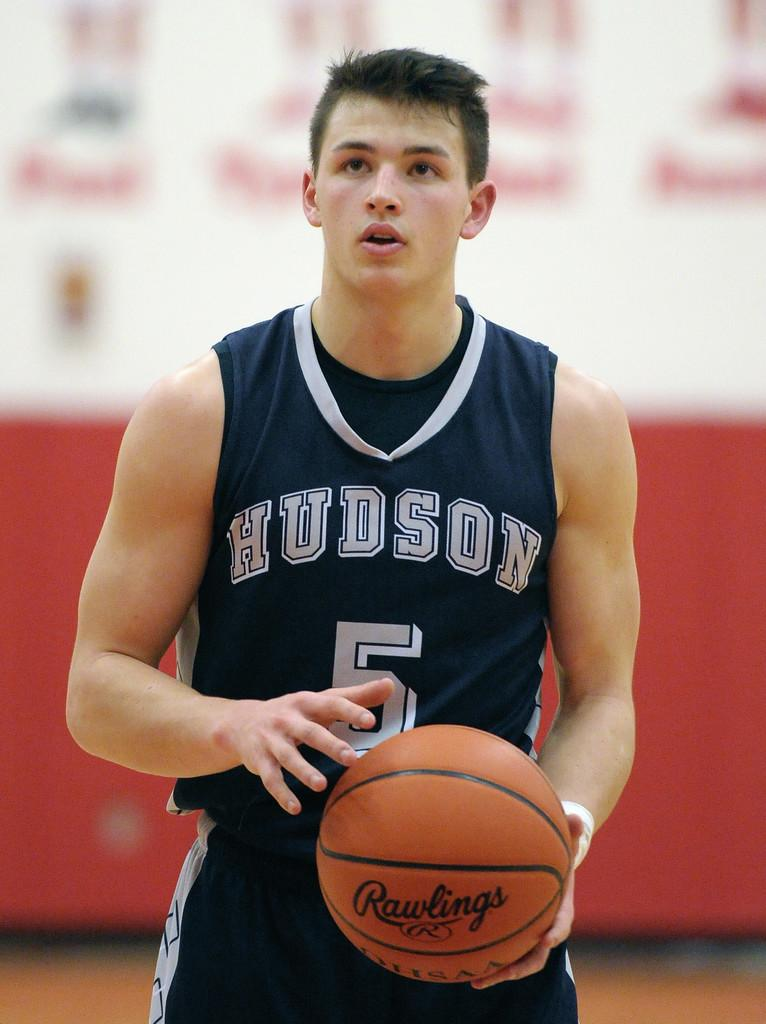<image>
Share a concise interpretation of the image provided. Basketball player holding a basketball with Rawlings on it. 